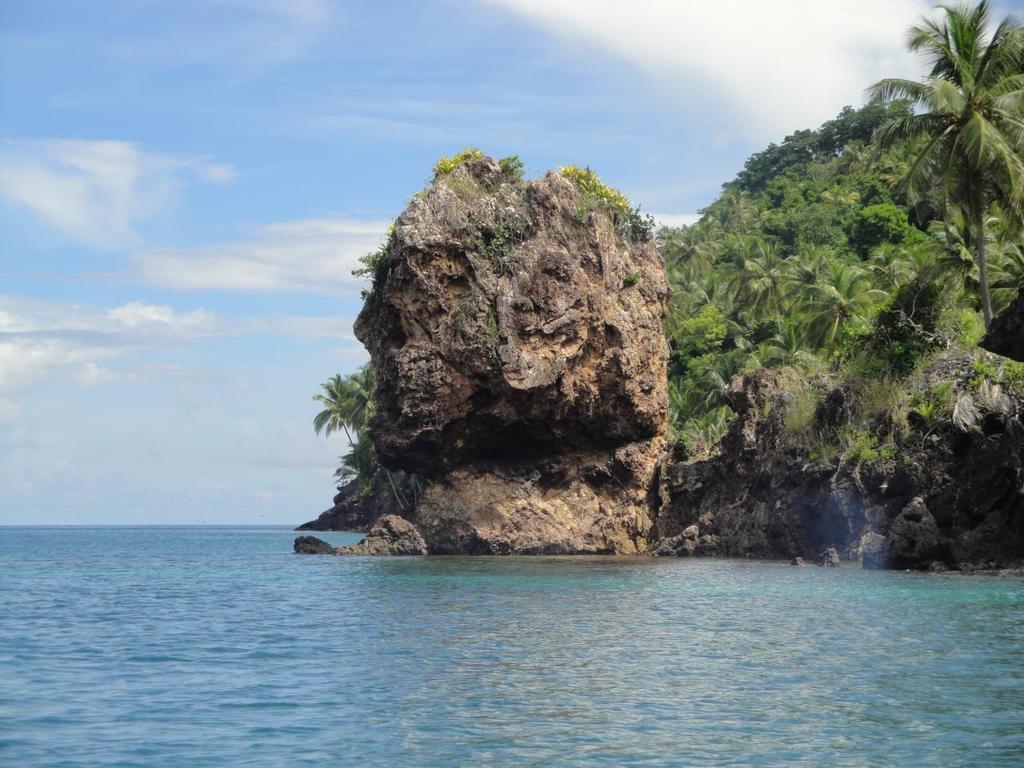Please provide a concise description of this image. In this image I can see a mountain and some trees from center to the right hand side of the image and at the top of the image I can see the sky at the bottom of the image I can see sea water. 